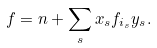Convert formula to latex. <formula><loc_0><loc_0><loc_500><loc_500>f = n + \sum _ { s } x _ { s } f _ { i _ { s } } y _ { s } .</formula> 